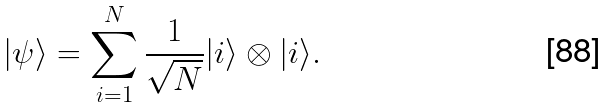<formula> <loc_0><loc_0><loc_500><loc_500>| \psi \rangle = \sum _ { i = 1 } ^ { N } \frac { 1 } { \sqrt { N } } | i \rangle \otimes | i \rangle .</formula> 